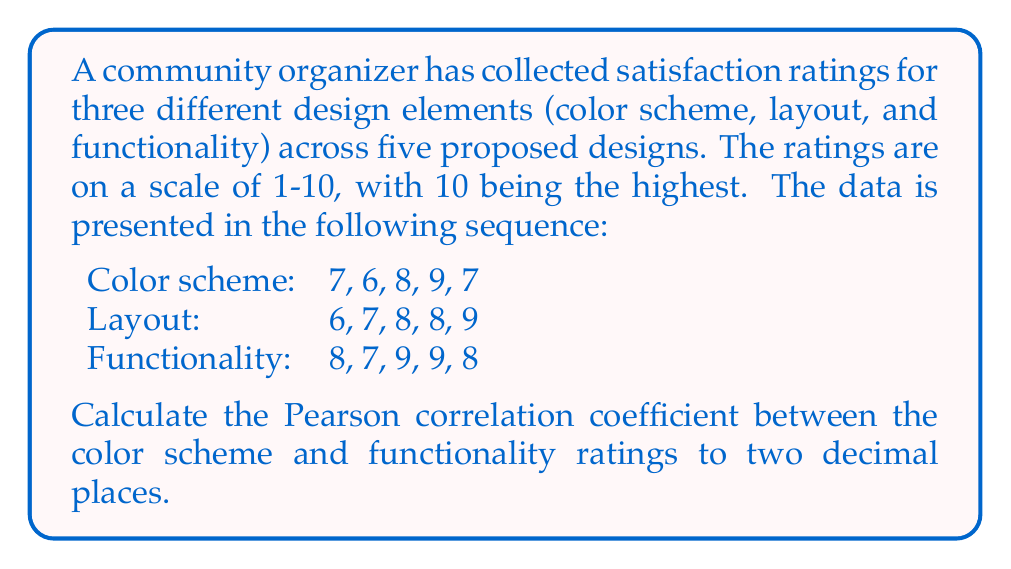Can you answer this question? To calculate the Pearson correlation coefficient (r) between color scheme (X) and functionality (Y) ratings, we'll use the formula:

$$ r = \frac{n\sum xy - \sum x \sum y}{\sqrt{[n\sum x^2 - (\sum x)^2][n\sum y^2 - (\sum y)^2]}} $$

Where n is the number of pairs.

Step 1: Calculate the necessary sums:
n = 5
$\sum x = 7 + 6 + 8 + 9 + 7 = 37$
$\sum y = 8 + 7 + 9 + 9 + 8 = 41$
$\sum xy = (7 * 8) + (6 * 7) + (8 * 9) + (9 * 9) + (7 * 8) = 56 + 42 + 72 + 81 + 56 = 307$
$\sum x^2 = 7^2 + 6^2 + 8^2 + 9^2 + 7^2 = 49 + 36 + 64 + 81 + 49 = 279$
$\sum y^2 = 8^2 + 7^2 + 9^2 + 9^2 + 8^2 = 64 + 49 + 81 + 81 + 64 = 339$

Step 2: Apply the formula:

$$ r = \frac{5(307) - (37)(41)}{\sqrt{[5(279) - (37)^2][5(339) - (41)^2]}} $$

Step 3: Simplify:

$$ r = \frac{1535 - 1517}{\sqrt{(1395 - 1369)(1695 - 1681)}} = \frac{18}{\sqrt{(26)(14)}} = \frac{18}{\sqrt{364}} = \frac{18}{19.08} $$

Step 4: Round to two decimal places:

$$ r \approx 0.94 $$
Answer: 0.94 